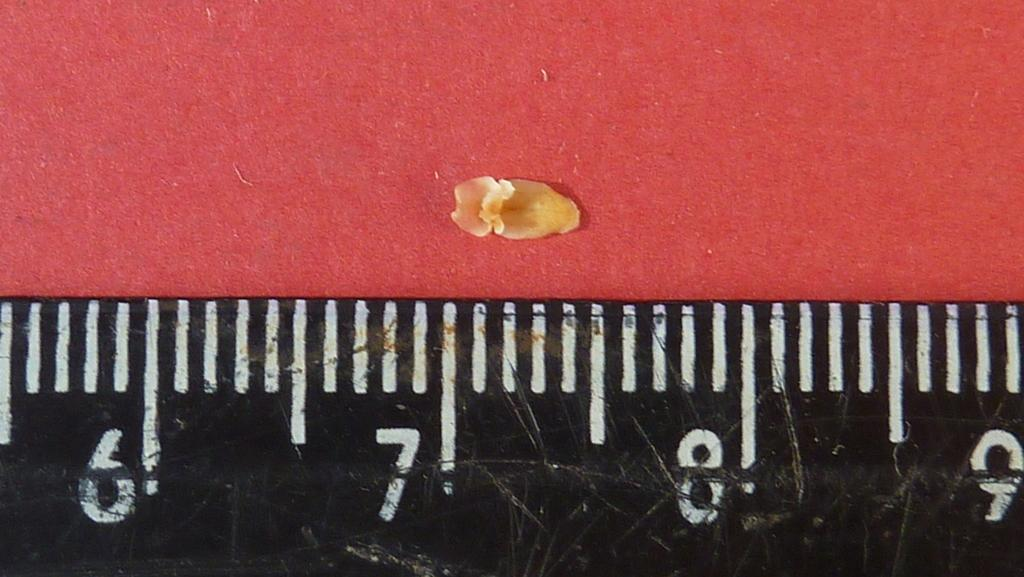<image>
Offer a succinct explanation of the picture presented. the front of a ruler with the numbers six ,seven eight and nine showing. 